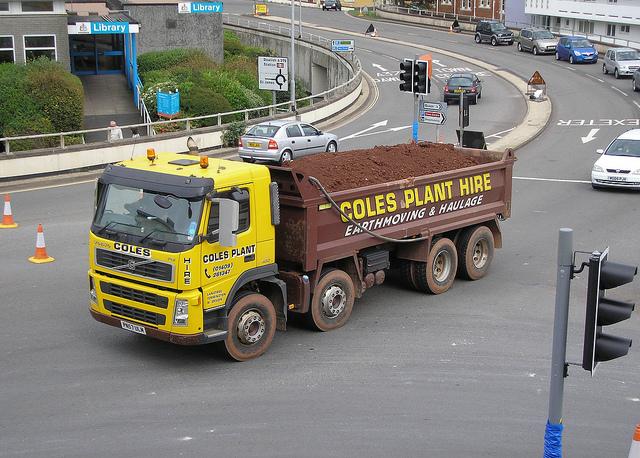What color is the truck?
Keep it brief. Yellow. What is the main color of this truck?
Quick response, please. Brown. What are there thousands of inside the building at the top left?
Answer briefly. Books. What is the truck hauling?
Write a very short answer. Dirt. 